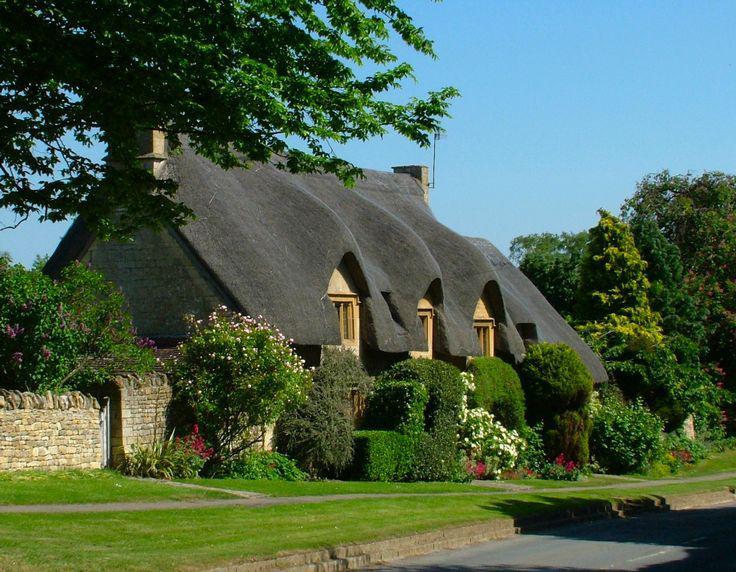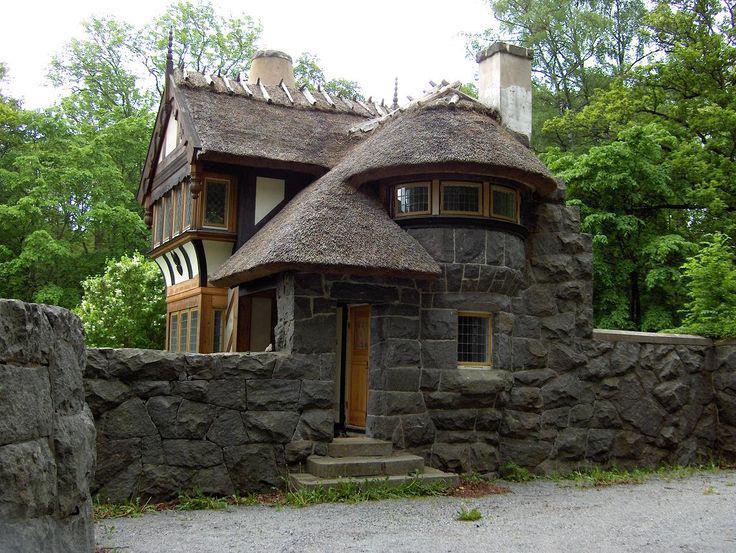The first image is the image on the left, the second image is the image on the right. Examine the images to the left and right. Is the description "In at least one image there is a yellow bricked house facing forward right with two chimney." accurate? Answer yes or no. Yes. The first image is the image on the left, the second image is the image on the right. For the images shown, is this caption "A house with a landscaped lawn has a roof with at least three notches around windows on its front side facing the street." true? Answer yes or no. Yes. 